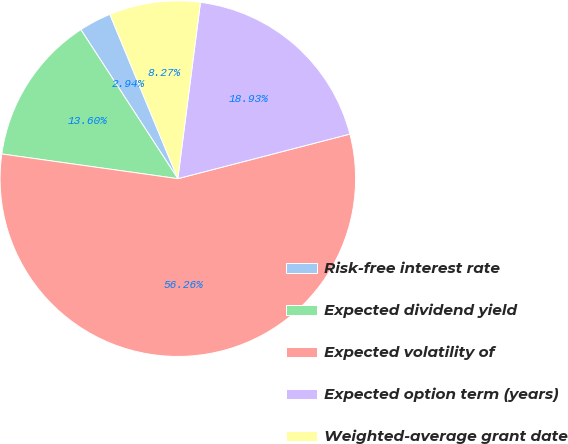Convert chart. <chart><loc_0><loc_0><loc_500><loc_500><pie_chart><fcel>Risk-free interest rate<fcel>Expected dividend yield<fcel>Expected volatility of<fcel>Expected option term (years)<fcel>Weighted-average grant date<nl><fcel>2.94%<fcel>13.6%<fcel>56.25%<fcel>18.93%<fcel>8.27%<nl></chart> 